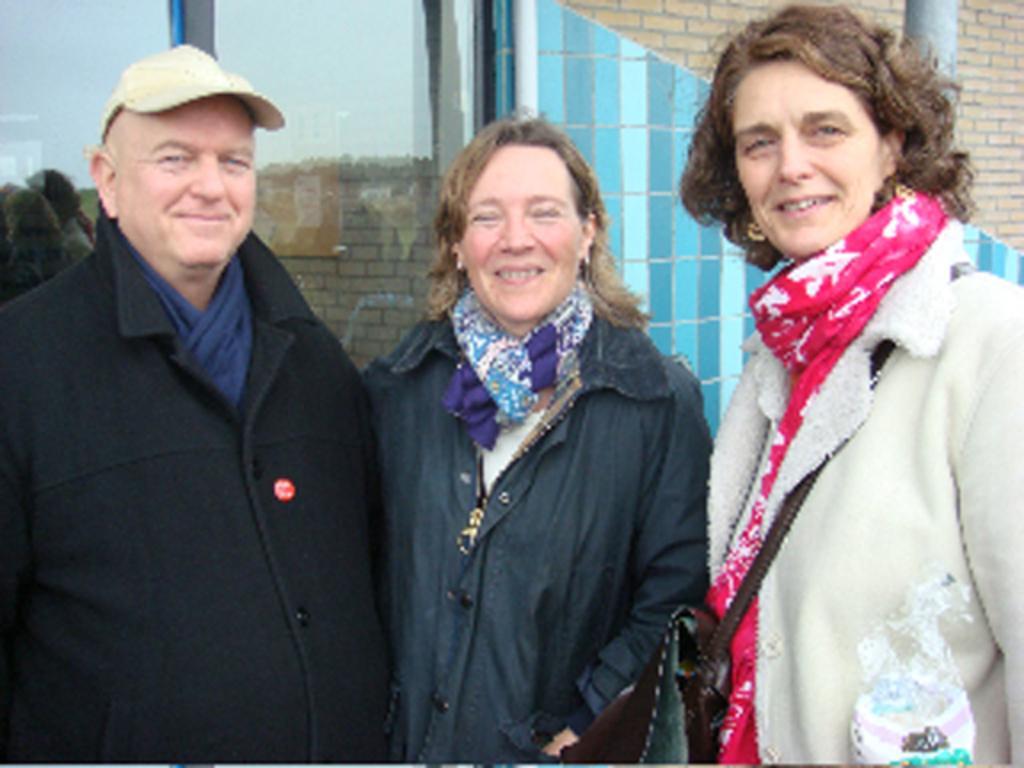Could you give a brief overview of what you see in this image? In the middle of the image three persons are standing and smiling. Behind them we can see a building. 